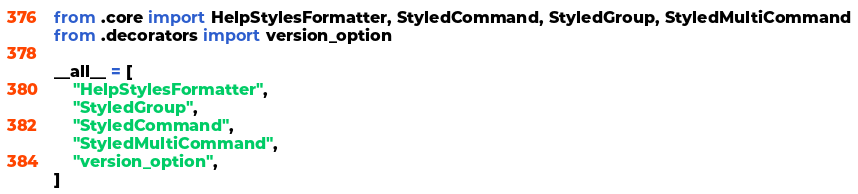<code> <loc_0><loc_0><loc_500><loc_500><_Python_>from .core import HelpStylesFormatter, StyledCommand, StyledGroup, StyledMultiCommand
from .decorators import version_option

__all__ = [
    "HelpStylesFormatter",
    "StyledGroup",
    "StyledCommand",
    "StyledMultiCommand",
    "version_option",
]</code> 